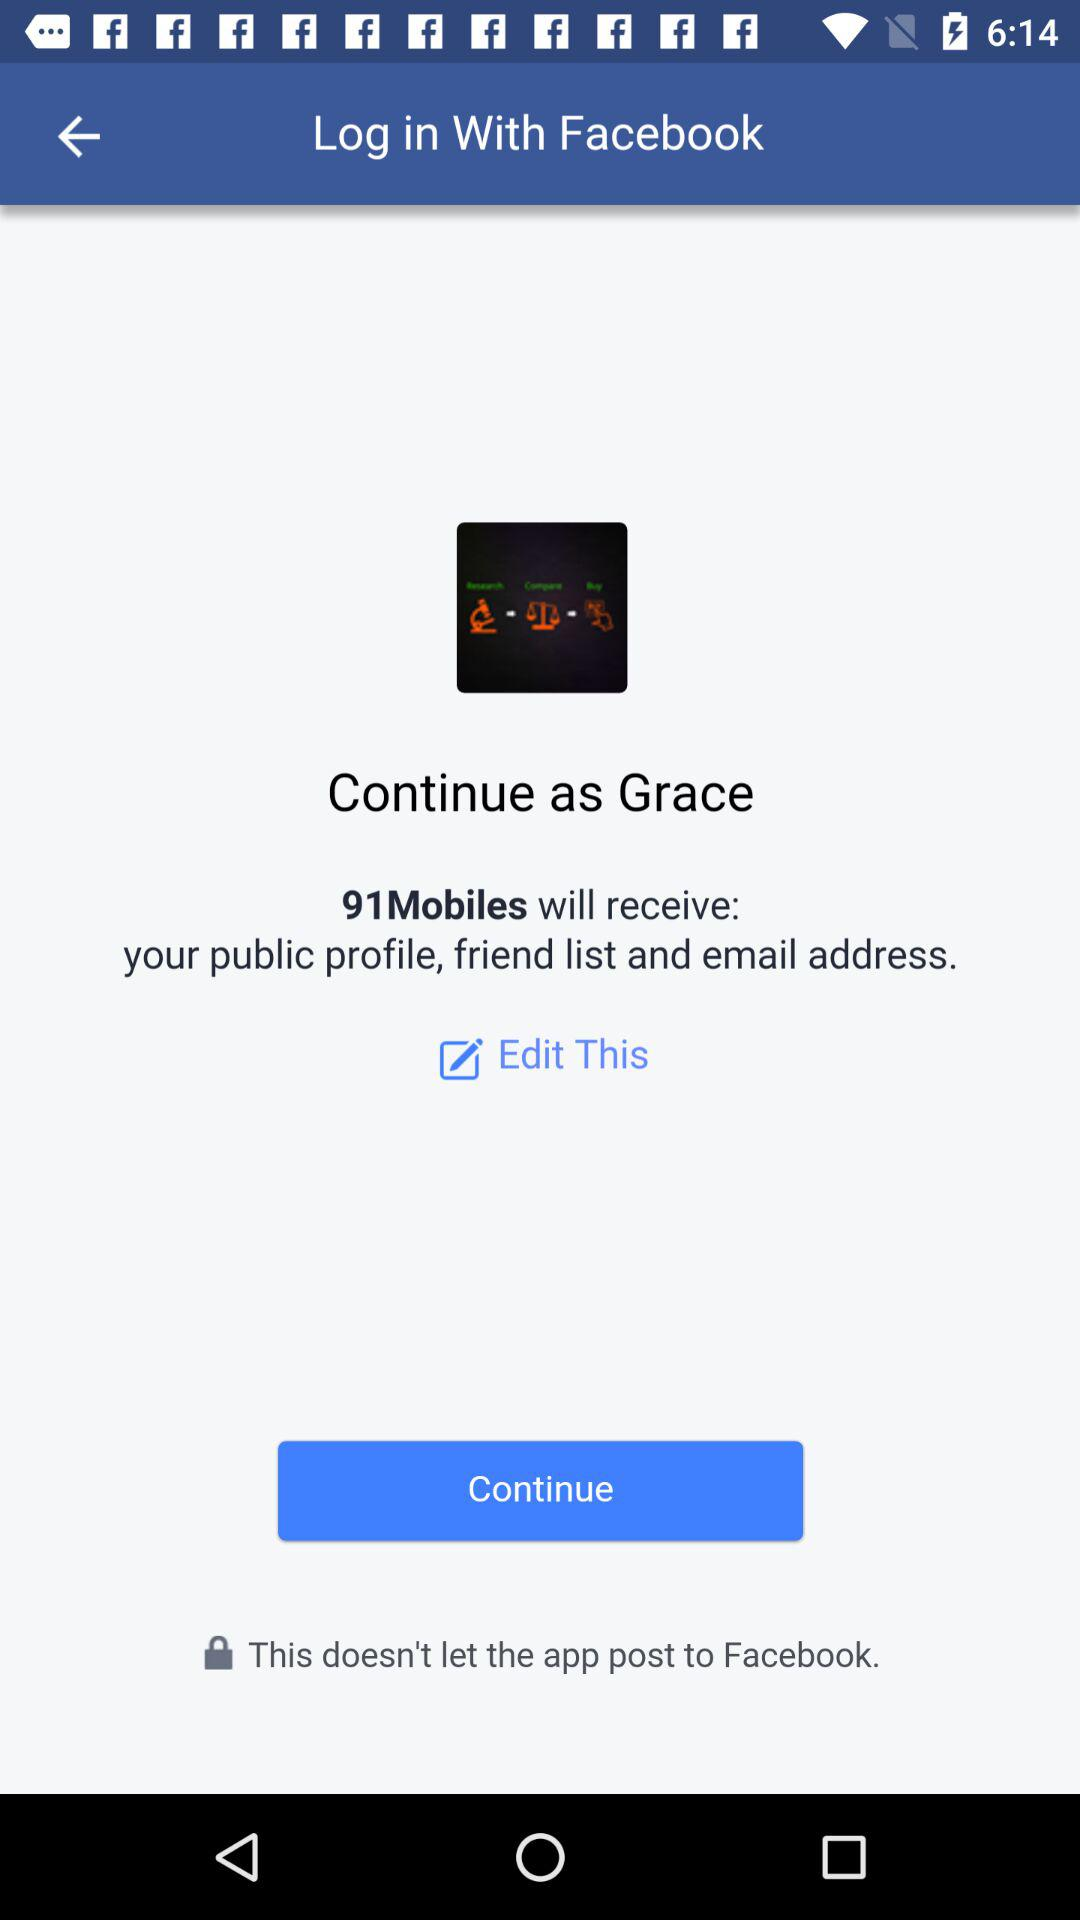What is the user name? The user name is Grace. 